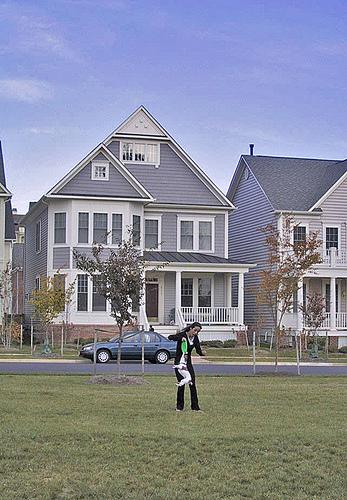How is the dog in midair? Please explain your reasoning. biting frisbee. He is hanging on to the frisbee. 